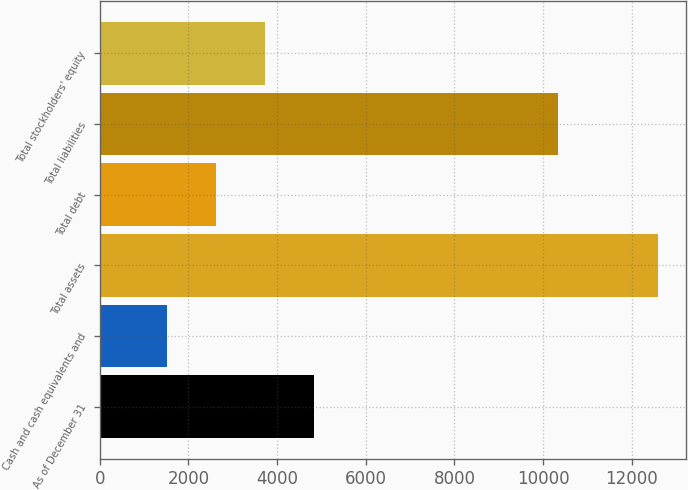<chart> <loc_0><loc_0><loc_500><loc_500><bar_chart><fcel>As of December 31<fcel>Cash and cash equivalents and<fcel>Total assets<fcel>Total debt<fcel>Total liabilities<fcel>Total stockholders' equity<nl><fcel>4832.32<fcel>1509.7<fcel>12585.1<fcel>2617.24<fcel>10331.4<fcel>3724.78<nl></chart> 